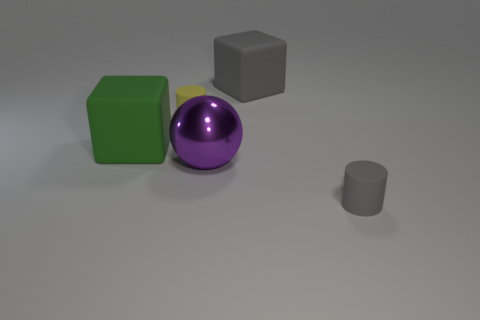Add 2 red metallic blocks. How many objects exist? 7 Subtract all cylinders. How many objects are left? 3 Subtract all small matte cylinders. Subtract all gray cylinders. How many objects are left? 2 Add 1 blocks. How many blocks are left? 3 Add 2 big purple metal balls. How many big purple metal balls exist? 3 Subtract 0 gray balls. How many objects are left? 5 